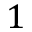Convert formula to latex. <formula><loc_0><loc_0><loc_500><loc_500>1</formula> 